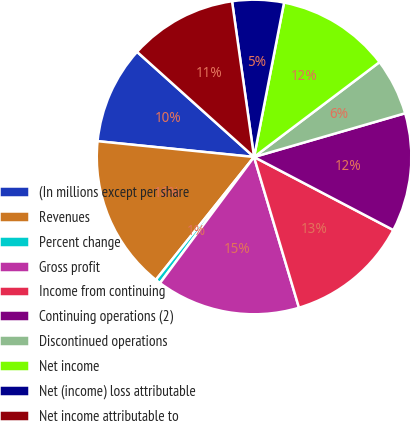<chart> <loc_0><loc_0><loc_500><loc_500><pie_chart><fcel>(In millions except per share<fcel>Revenues<fcel>Percent change<fcel>Gross profit<fcel>Income from continuing<fcel>Continuing operations (2)<fcel>Discontinued operations<fcel>Net income<fcel>Net (income) loss attributable<fcel>Net income attributable to<nl><fcel>10.05%<fcel>15.87%<fcel>0.53%<fcel>14.81%<fcel>12.7%<fcel>12.17%<fcel>5.82%<fcel>11.64%<fcel>5.29%<fcel>11.11%<nl></chart> 